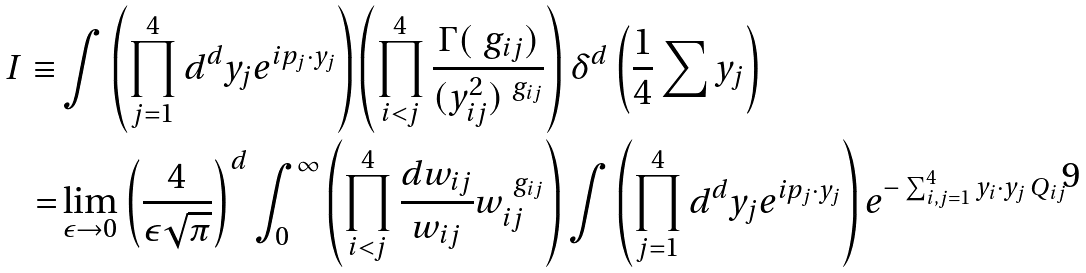<formula> <loc_0><loc_0><loc_500><loc_500>I \equiv & \int \left ( \prod _ { j = 1 } ^ { 4 } d ^ { d } y _ { j } e ^ { i p _ { j } \cdot y _ { j } } \right ) \left ( \prod _ { i < j } ^ { 4 } \frac { \Gamma ( \ g _ { i j } ) } { ( y _ { i j } ^ { 2 } ) ^ { \ g _ { i j } } } \right ) \delta ^ { d } \left ( \frac { 1 } { 4 } \sum y _ { j } \right ) \\ = & \lim _ { \epsilon \to 0 } \left ( \frac { 4 } { \epsilon \sqrt { \pi } } \right ) ^ { d } \int _ { 0 } ^ { \infty } \left ( \prod _ { i < j } ^ { 4 } \frac { d w _ { i j } } { w _ { i j } } w _ { i j } ^ { \ g _ { i j } } \right ) \int \left ( \prod _ { j = 1 } ^ { 4 } d ^ { d } y _ { j } e ^ { i p _ { j } \cdot y _ { j } } \right ) e ^ { - \sum _ { i , j = 1 } ^ { 4 } y _ { i } \cdot y _ { j } \, Q _ { i j } }</formula> 